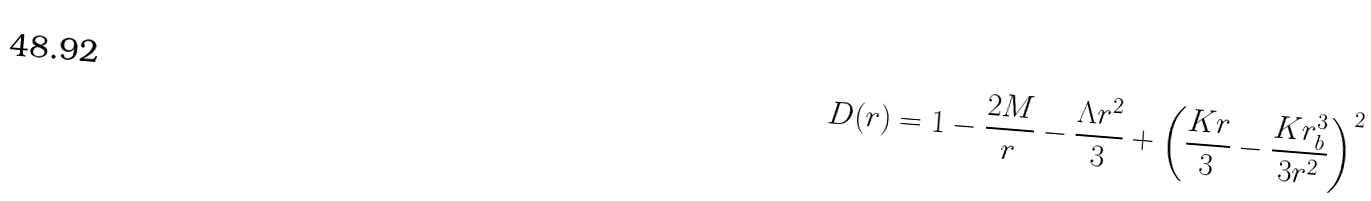Convert formula to latex. <formula><loc_0><loc_0><loc_500><loc_500>D ( r ) = 1 - \frac { 2 M } { r } - \frac { \Lambda r ^ { 2 } } { 3 } + \left ( \frac { K r } { 3 } - \frac { K r _ { b } ^ { 3 } } { 3 r ^ { 2 } } \right ) ^ { 2 }</formula> 